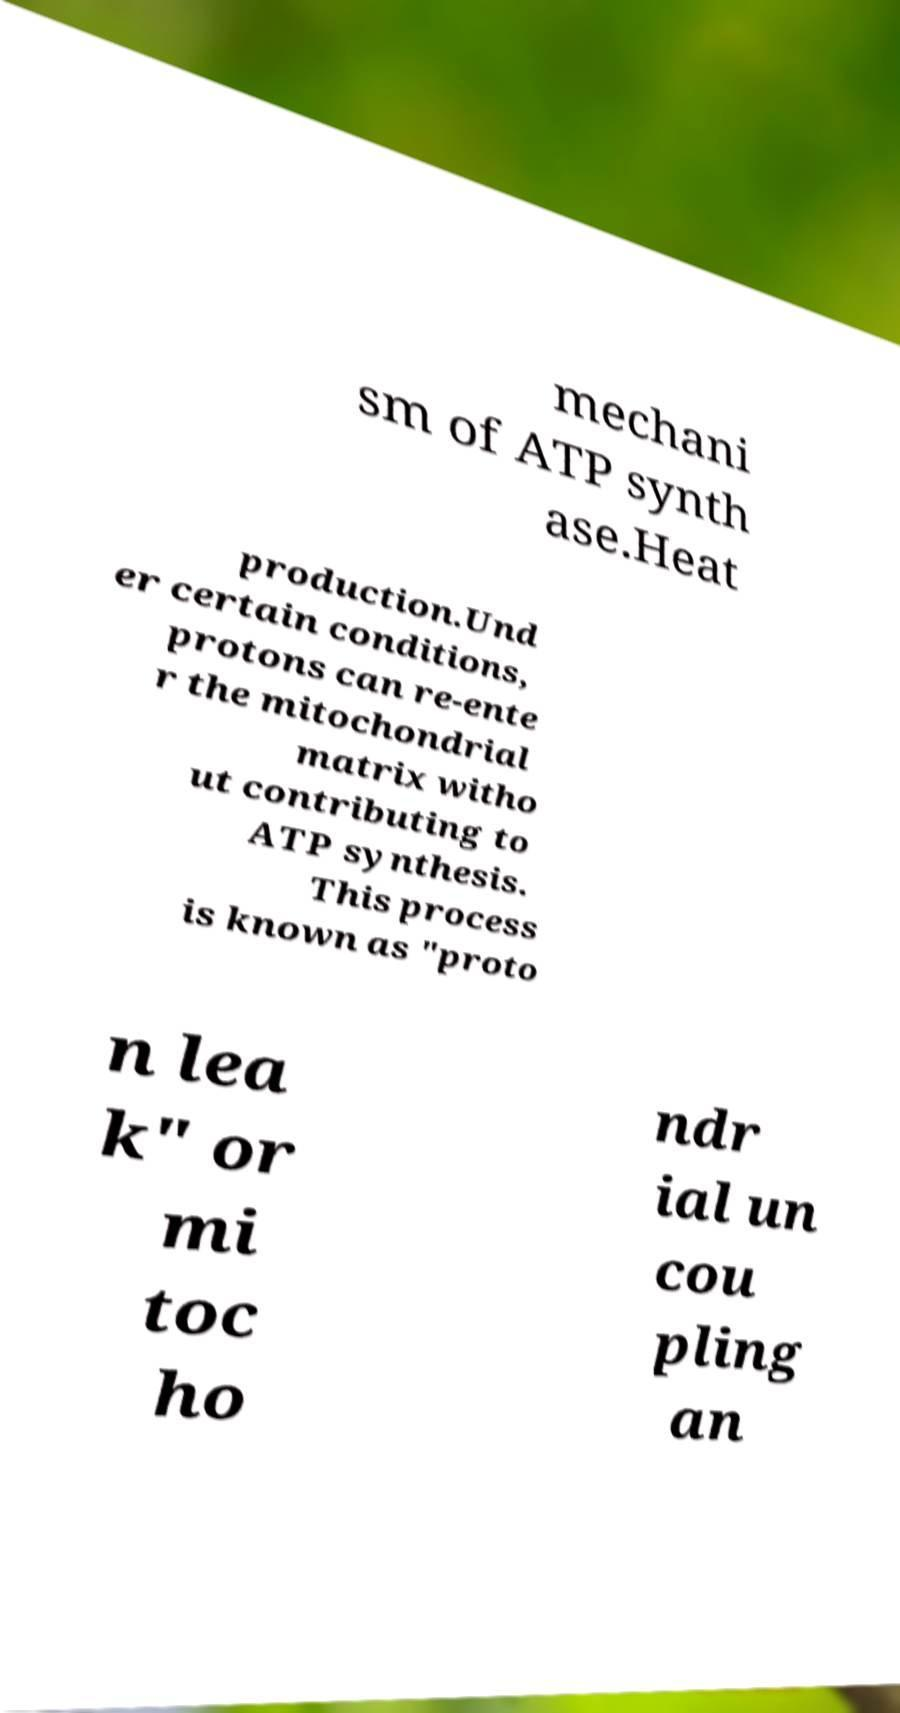For documentation purposes, I need the text within this image transcribed. Could you provide that? mechani sm of ATP synth ase.Heat production.Und er certain conditions, protons can re-ente r the mitochondrial matrix witho ut contributing to ATP synthesis. This process is known as "proto n lea k" or mi toc ho ndr ial un cou pling an 